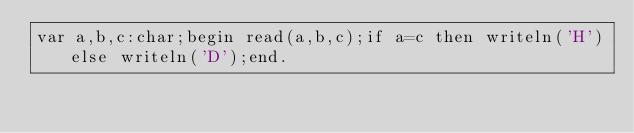Convert code to text. <code><loc_0><loc_0><loc_500><loc_500><_Pascal_>var a,b,c:char;begin read(a,b,c);if a=c then writeln('H')else writeln('D');end. </code> 